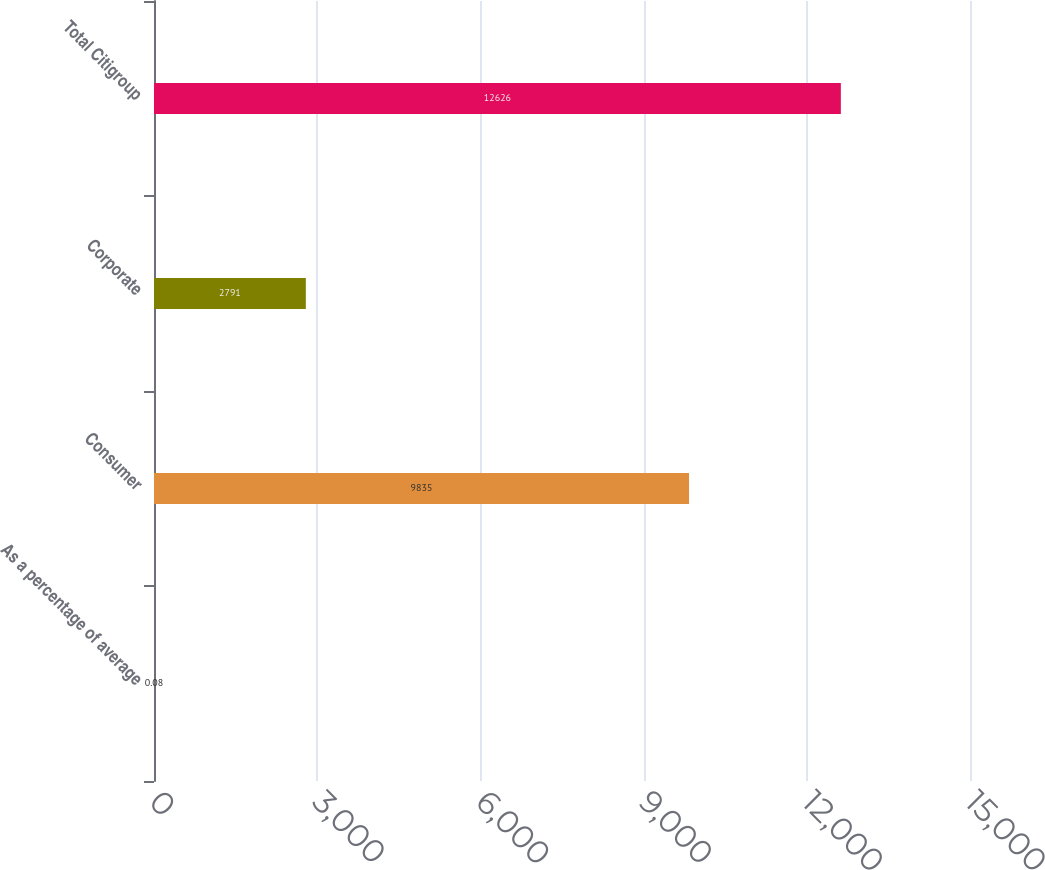<chart> <loc_0><loc_0><loc_500><loc_500><bar_chart><fcel>As a percentage of average<fcel>Consumer<fcel>Corporate<fcel>Total Citigroup<nl><fcel>0.08<fcel>9835<fcel>2791<fcel>12626<nl></chart> 